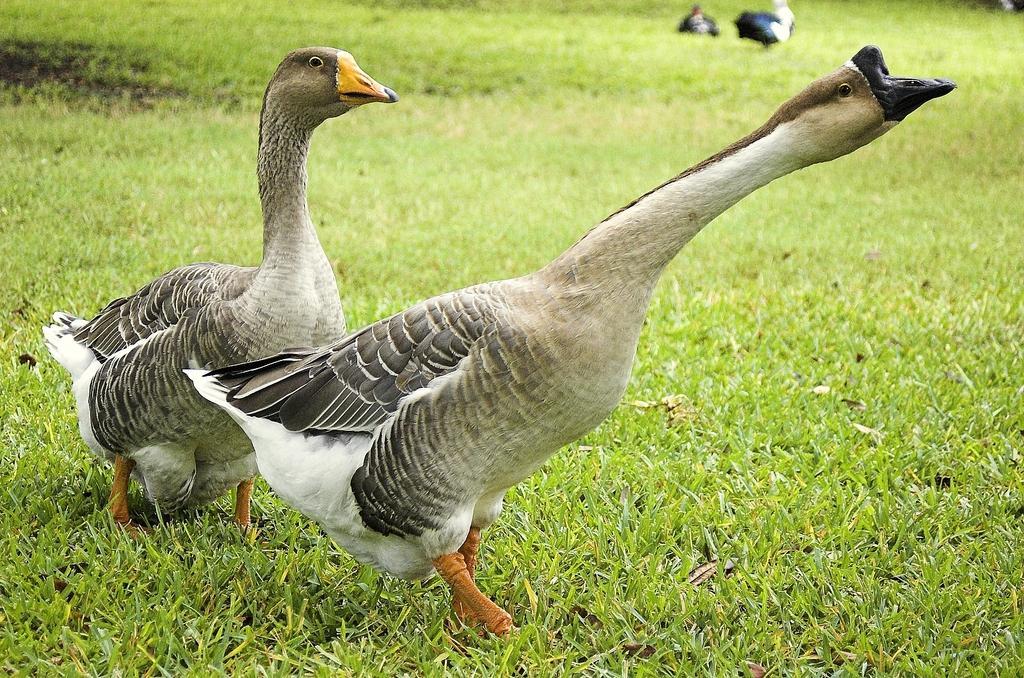Can you describe this image briefly? In the center of the image there are two ducks. At the bottom of the image there is grass. 